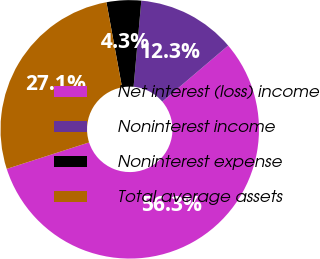<chart> <loc_0><loc_0><loc_500><loc_500><pie_chart><fcel>Net interest (loss) income<fcel>Noninterest income<fcel>Noninterest expense<fcel>Total average assets<nl><fcel>56.28%<fcel>12.35%<fcel>4.32%<fcel>27.06%<nl></chart> 